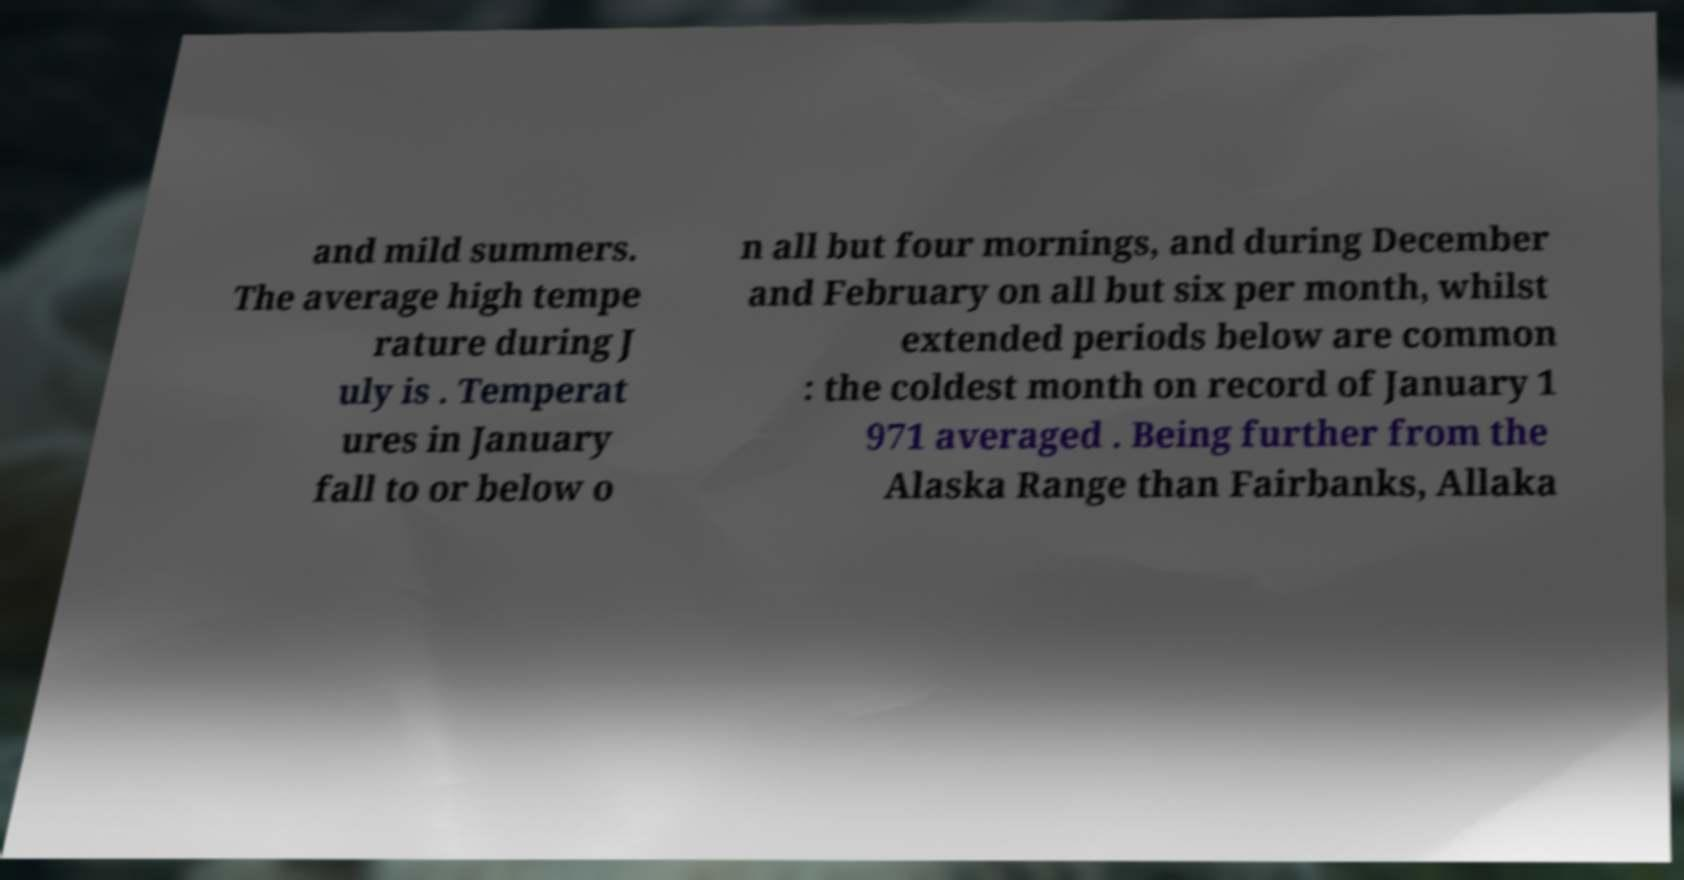For documentation purposes, I need the text within this image transcribed. Could you provide that? and mild summers. The average high tempe rature during J uly is . Temperat ures in January fall to or below o n all but four mornings, and during December and February on all but six per month, whilst extended periods below are common : the coldest month on record of January 1 971 averaged . Being further from the Alaska Range than Fairbanks, Allaka 